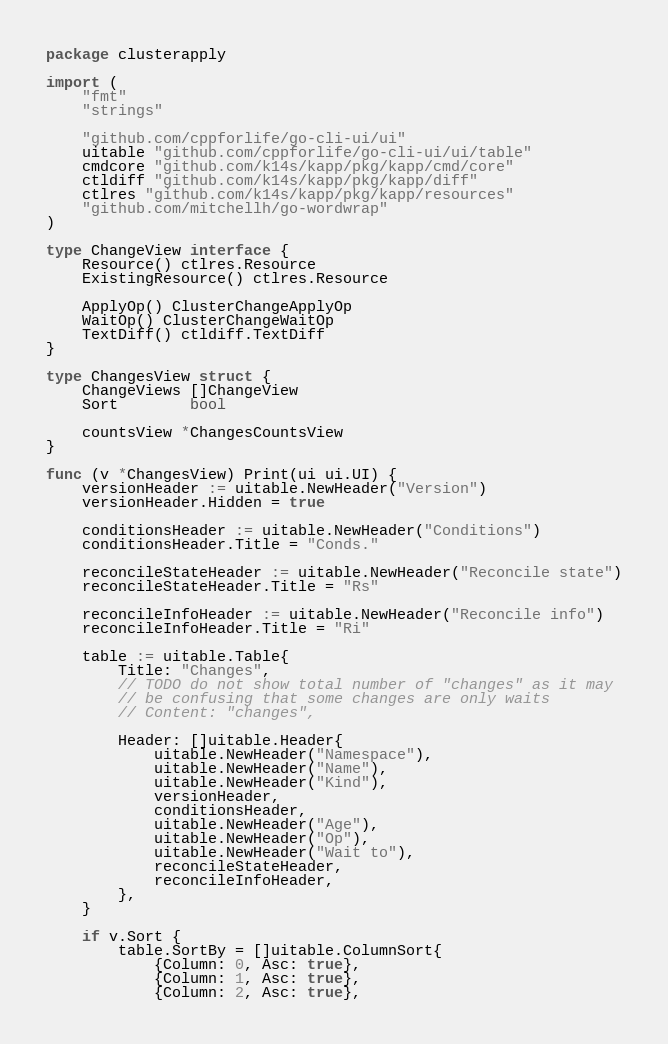Convert code to text. <code><loc_0><loc_0><loc_500><loc_500><_Go_>package clusterapply

import (
	"fmt"
	"strings"

	"github.com/cppforlife/go-cli-ui/ui"
	uitable "github.com/cppforlife/go-cli-ui/ui/table"
	cmdcore "github.com/k14s/kapp/pkg/kapp/cmd/core"
	ctldiff "github.com/k14s/kapp/pkg/kapp/diff"
	ctlres "github.com/k14s/kapp/pkg/kapp/resources"
	"github.com/mitchellh/go-wordwrap"
)

type ChangeView interface {
	Resource() ctlres.Resource
	ExistingResource() ctlres.Resource

	ApplyOp() ClusterChangeApplyOp
	WaitOp() ClusterChangeWaitOp
	TextDiff() ctldiff.TextDiff
}

type ChangesView struct {
	ChangeViews []ChangeView
	Sort        bool

	countsView *ChangesCountsView
}

func (v *ChangesView) Print(ui ui.UI) {
	versionHeader := uitable.NewHeader("Version")
	versionHeader.Hidden = true

	conditionsHeader := uitable.NewHeader("Conditions")
	conditionsHeader.Title = "Conds."

	reconcileStateHeader := uitable.NewHeader("Reconcile state")
	reconcileStateHeader.Title = "Rs"

	reconcileInfoHeader := uitable.NewHeader("Reconcile info")
	reconcileInfoHeader.Title = "Ri"

	table := uitable.Table{
		Title: "Changes",
		// TODO do not show total number of "changes" as it may
		// be confusing that some changes are only waits
		// Content: "changes",

		Header: []uitable.Header{
			uitable.NewHeader("Namespace"),
			uitable.NewHeader("Name"),
			uitable.NewHeader("Kind"),
			versionHeader,
			conditionsHeader,
			uitable.NewHeader("Age"),
			uitable.NewHeader("Op"),
			uitable.NewHeader("Wait to"),
			reconcileStateHeader,
			reconcileInfoHeader,
		},
	}

	if v.Sort {
		table.SortBy = []uitable.ColumnSort{
			{Column: 0, Asc: true},
			{Column: 1, Asc: true},
			{Column: 2, Asc: true},</code> 